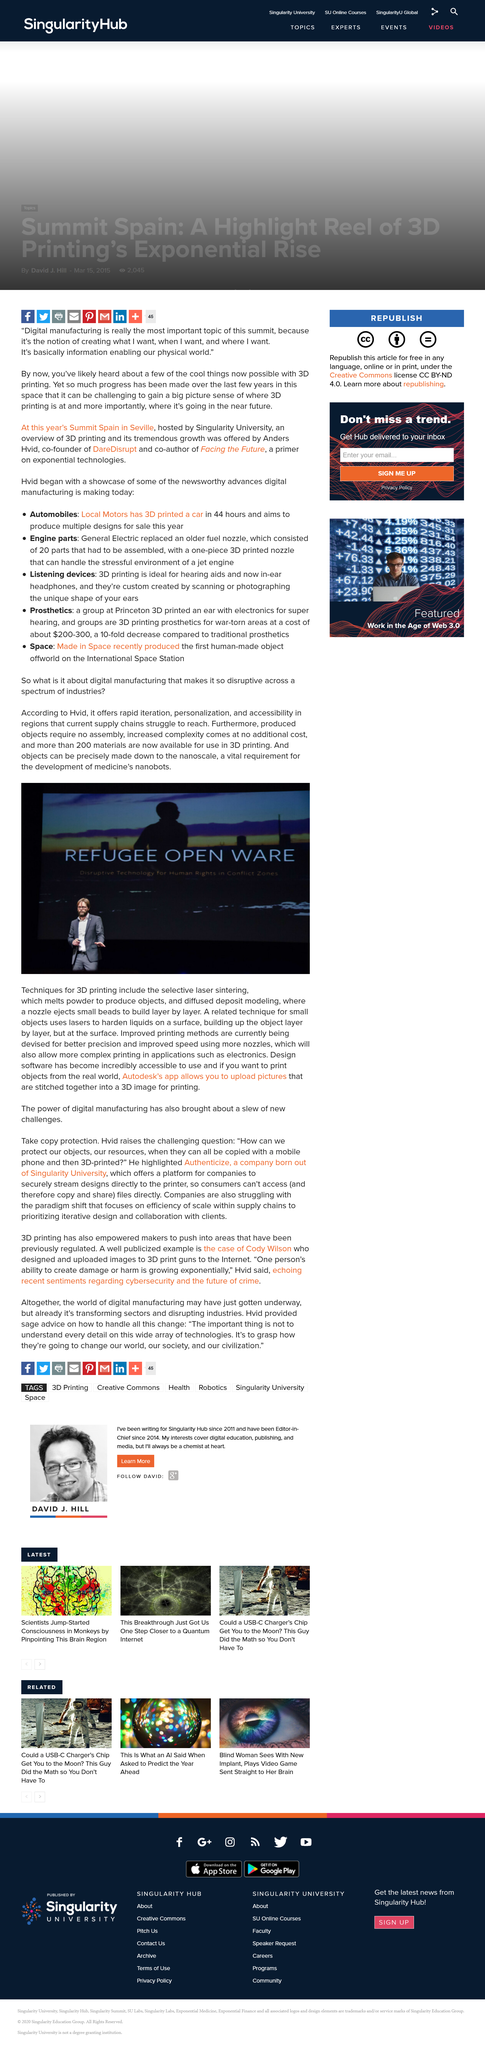Indicate a few pertinent items in this graphic. The development of nanobots in medicine requires the use of nanoscale development as a vital requirement. There are now over 200 materials that are available for use in 3D printing. Autodesk's app allows users to upload pictures and stitch them together into a 3D image that can be printed. 